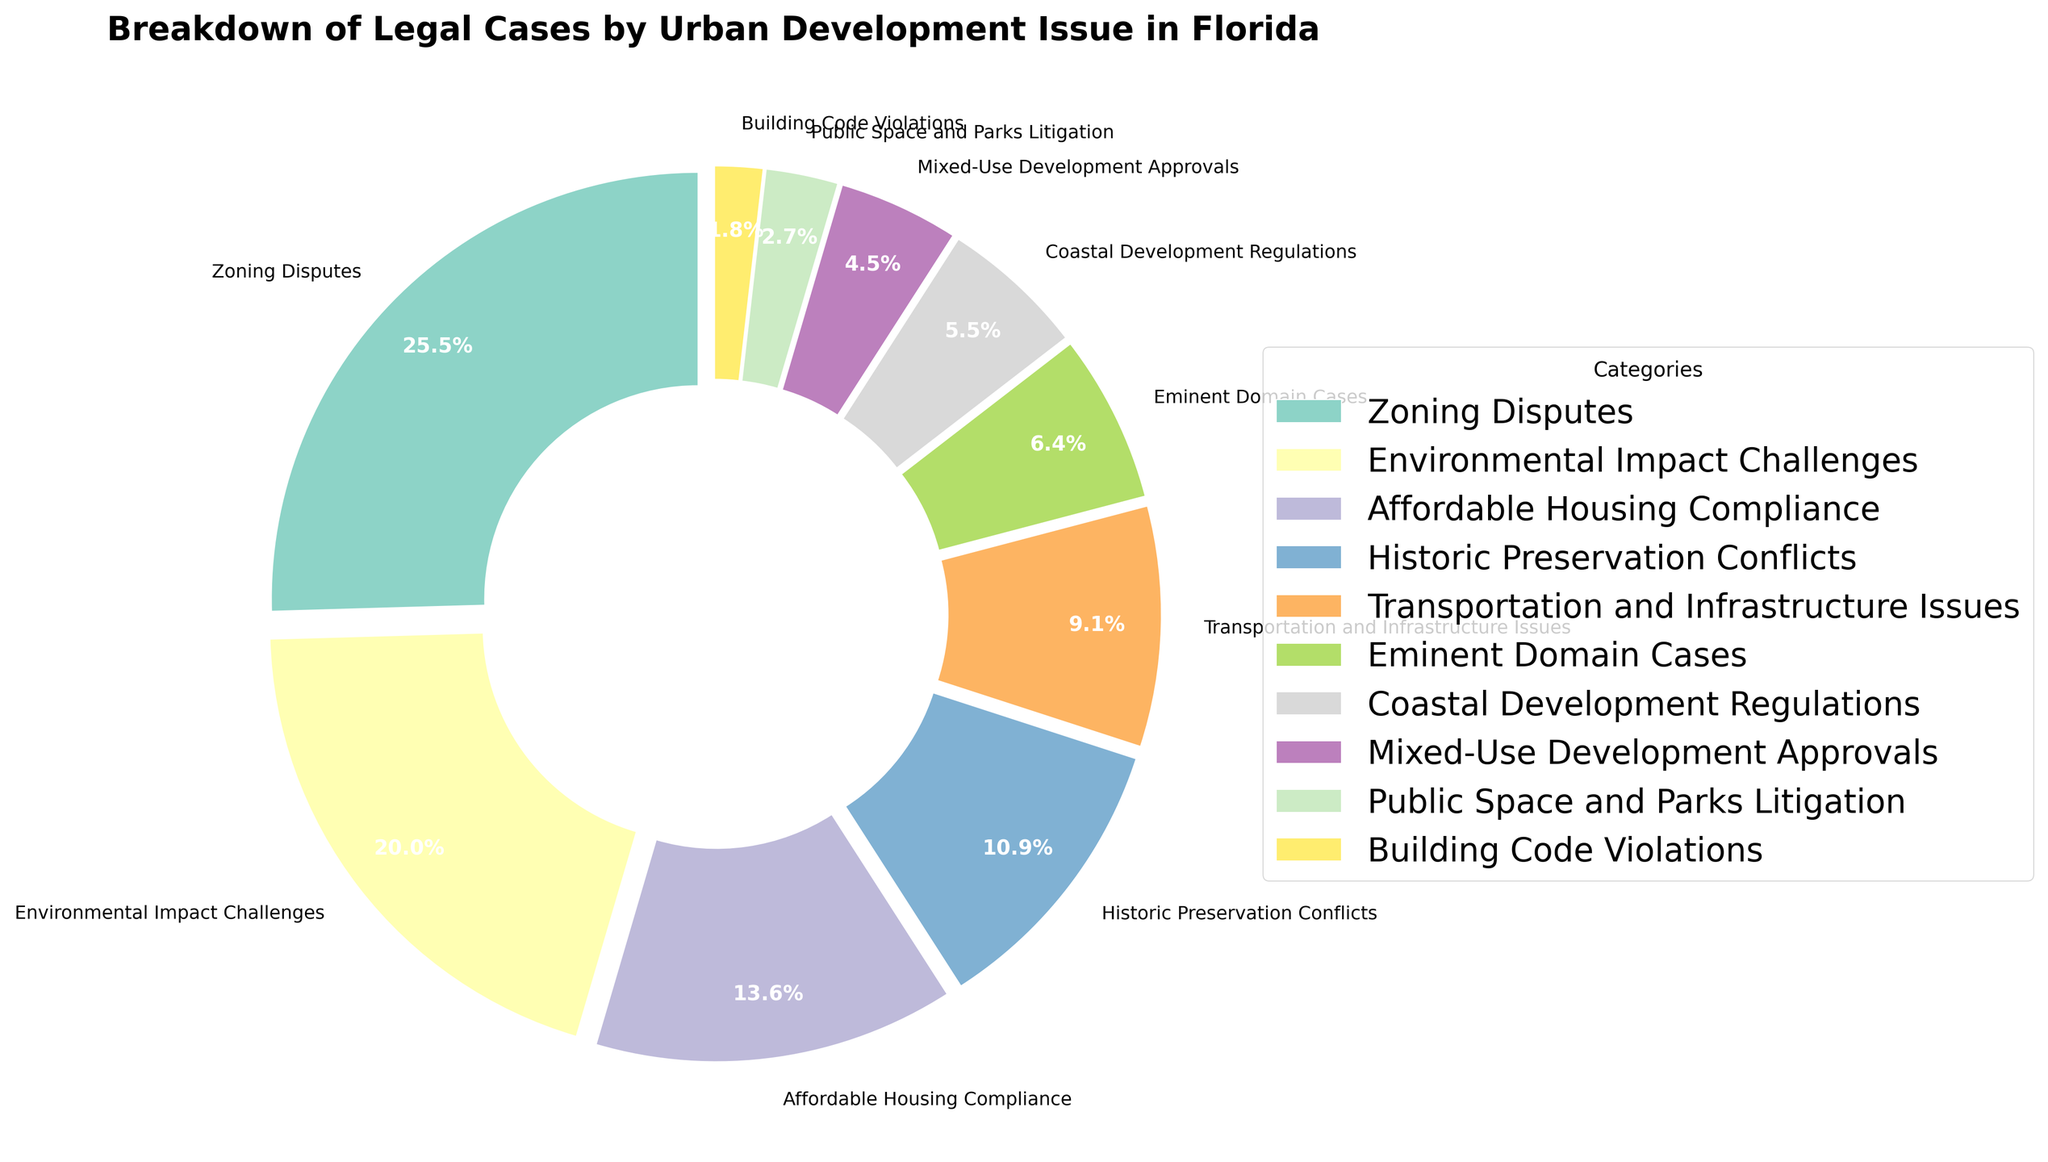Which category has the highest percentage of legal cases? The largest slice in the pie chart represents the highest percentage. From the chart, the 'Zoning Disputes' category has the highest percentage.
Answer: Zoning Disputes What is the combined percentage of legal cases related to 'Environmental Impact Challenges' and 'Affordable Housing Compliance'? Add the percentages of 'Environmental Impact Challenges' (22%) and 'Affordable Housing Compliance' (15%). The combined percentage is 22% + 15% = 37%.
Answer: 37% Is the percentage of 'Historic Preservation Conflicts' greater than the percentage of 'Transportation and Infrastructure Issues'? Compare the percentages of the two categories. 'Historic Preservation Conflicts' is 12% and 'Transportation and Infrastructure Issues' is 10%. Since 12% > 10%, 'Historic Preservation Conflicts' has a greater percentage.
Answer: Yes What is the difference in the percentage between 'Eminent Domain Cases' and 'Coastal Development Regulations'? Subtract the percentage of 'Coastal Development Regulations' (6%) from 'Eminent Domain Cases' (7%). The difference is 7% - 6% = 1%.
Answer: 1% Which category has the smallest percentage of legal cases? The smallest slice in the pie chart represents the category with the smallest percentage. 'Building Code Violations' has the smallest percentage at 2%.
Answer: Building Code Violations How many categories have a percentage greater than 10%? Identify and count categories with percentages greater than 10%. They are 'Zoning Disputes' (28%), 'Environmental Impact Challenges' (22%), 'Affordable Housing Compliance' (15%), and 'Historic Preservation Conflicts' (12%). There are 4 such categories.
Answer: 4 What is the ratio of the percentage of 'Zoning Disputes' to 'Public Space and Parks Litigation'? Divide the percentage of 'Zoning Disputes' (28%) by 'Public Space and Parks Litigation' (3%). The ratio is 28% / 3% ≈ 9.33.
Answer: 9.33 Among 'Mixed-Use Development Approvals' and 'Coastal Development Regulations', which has a lower percentage and by how much? Compare the percentages of 'Mixed-Use Development Approvals' (5%) and 'Coastal Development Regulations' (6%). 'Mixed-Use Development Approvals' has a lower percentage by 6% - 5% = 1%.
Answer: Mixed-Use Development Approvals, 1% 